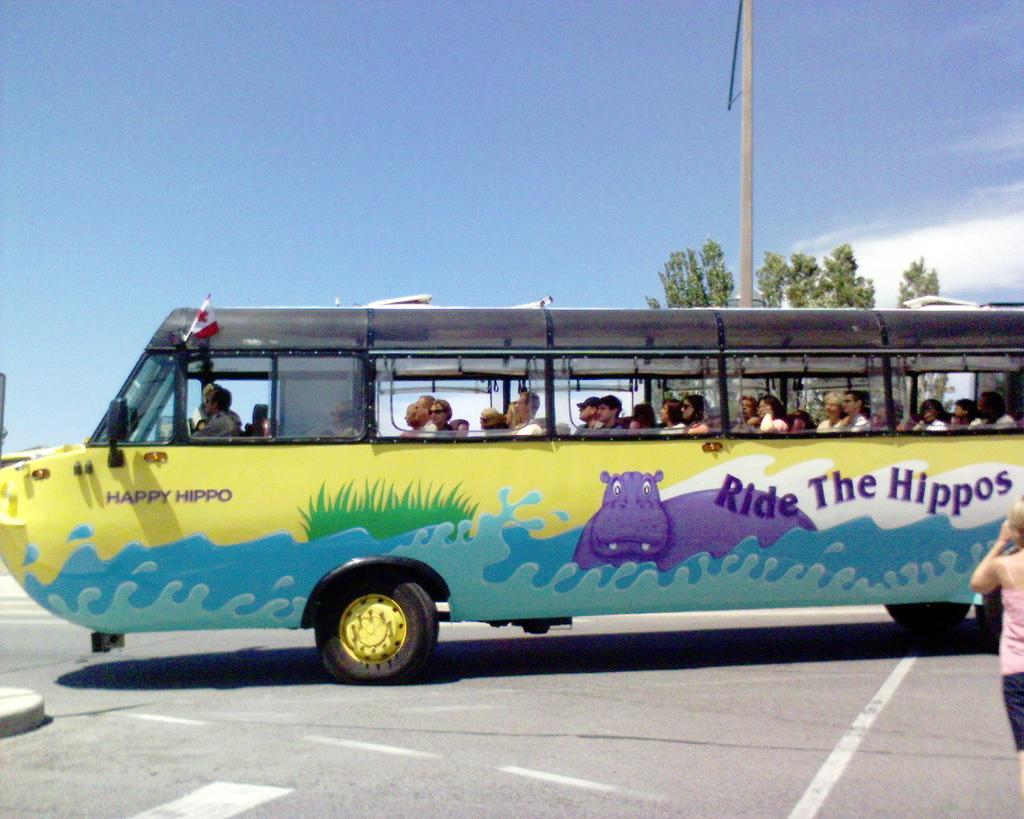<image>
Offer a succinct explanation of the picture presented. A bus that can float on water that says Ride The Hippos on the side of it. 